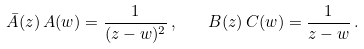<formula> <loc_0><loc_0><loc_500><loc_500>\bar { A } ( z ) \, A ( w ) = \frac { 1 } { ( z - w ) ^ { 2 } } \, , \quad B ( z ) \, C ( w ) = \frac { 1 } { z - w } \, .</formula> 